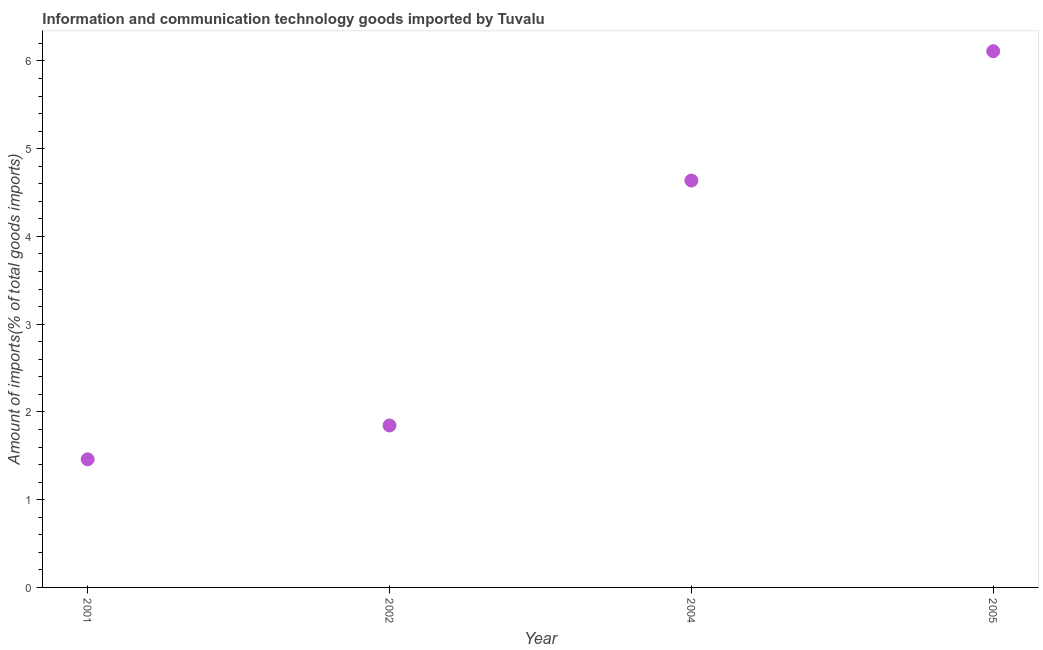What is the amount of ict goods imports in 2005?
Make the answer very short. 6.11. Across all years, what is the maximum amount of ict goods imports?
Provide a short and direct response. 6.11. Across all years, what is the minimum amount of ict goods imports?
Keep it short and to the point. 1.46. In which year was the amount of ict goods imports maximum?
Give a very brief answer. 2005. What is the sum of the amount of ict goods imports?
Your answer should be very brief. 14.05. What is the difference between the amount of ict goods imports in 2004 and 2005?
Your response must be concise. -1.47. What is the average amount of ict goods imports per year?
Offer a terse response. 3.51. What is the median amount of ict goods imports?
Make the answer very short. 3.24. In how many years, is the amount of ict goods imports greater than 5.8 %?
Provide a succinct answer. 1. What is the ratio of the amount of ict goods imports in 2001 to that in 2005?
Give a very brief answer. 0.24. What is the difference between the highest and the second highest amount of ict goods imports?
Offer a terse response. 1.47. Is the sum of the amount of ict goods imports in 2002 and 2004 greater than the maximum amount of ict goods imports across all years?
Ensure brevity in your answer.  Yes. What is the difference between the highest and the lowest amount of ict goods imports?
Ensure brevity in your answer.  4.65. How many dotlines are there?
Ensure brevity in your answer.  1. Does the graph contain any zero values?
Keep it short and to the point. No. Does the graph contain grids?
Give a very brief answer. No. What is the title of the graph?
Your answer should be compact. Information and communication technology goods imported by Tuvalu. What is the label or title of the X-axis?
Make the answer very short. Year. What is the label or title of the Y-axis?
Offer a terse response. Amount of imports(% of total goods imports). What is the Amount of imports(% of total goods imports) in 2001?
Offer a very short reply. 1.46. What is the Amount of imports(% of total goods imports) in 2002?
Make the answer very short. 1.85. What is the Amount of imports(% of total goods imports) in 2004?
Your answer should be compact. 4.64. What is the Amount of imports(% of total goods imports) in 2005?
Your answer should be compact. 6.11. What is the difference between the Amount of imports(% of total goods imports) in 2001 and 2002?
Your answer should be compact. -0.39. What is the difference between the Amount of imports(% of total goods imports) in 2001 and 2004?
Offer a very short reply. -3.18. What is the difference between the Amount of imports(% of total goods imports) in 2001 and 2005?
Give a very brief answer. -4.65. What is the difference between the Amount of imports(% of total goods imports) in 2002 and 2004?
Your response must be concise. -2.79. What is the difference between the Amount of imports(% of total goods imports) in 2002 and 2005?
Keep it short and to the point. -4.26. What is the difference between the Amount of imports(% of total goods imports) in 2004 and 2005?
Offer a terse response. -1.47. What is the ratio of the Amount of imports(% of total goods imports) in 2001 to that in 2002?
Provide a succinct answer. 0.79. What is the ratio of the Amount of imports(% of total goods imports) in 2001 to that in 2004?
Your answer should be compact. 0.32. What is the ratio of the Amount of imports(% of total goods imports) in 2001 to that in 2005?
Offer a terse response. 0.24. What is the ratio of the Amount of imports(% of total goods imports) in 2002 to that in 2004?
Provide a short and direct response. 0.4. What is the ratio of the Amount of imports(% of total goods imports) in 2002 to that in 2005?
Make the answer very short. 0.3. What is the ratio of the Amount of imports(% of total goods imports) in 2004 to that in 2005?
Offer a very short reply. 0.76. 